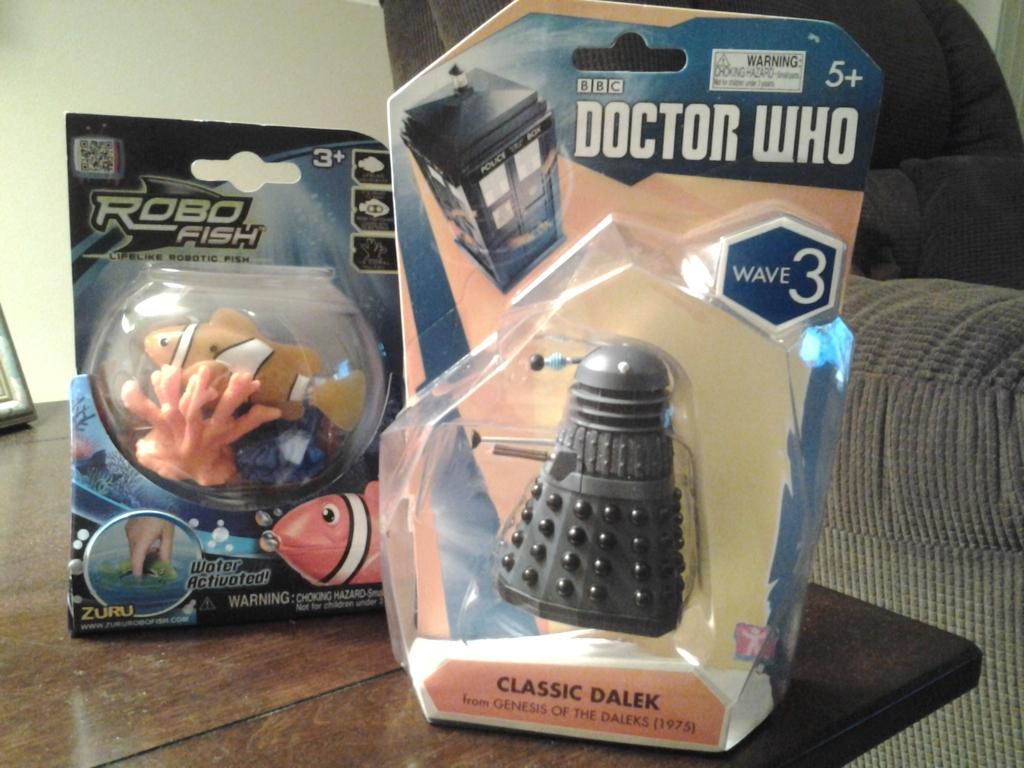In one or two sentences, can you explain what this image depicts? In this picture I can see there are toy fishes and a few other toys placed on the wooden table and there is a couch at right side and there is a wall in the backdrop. 